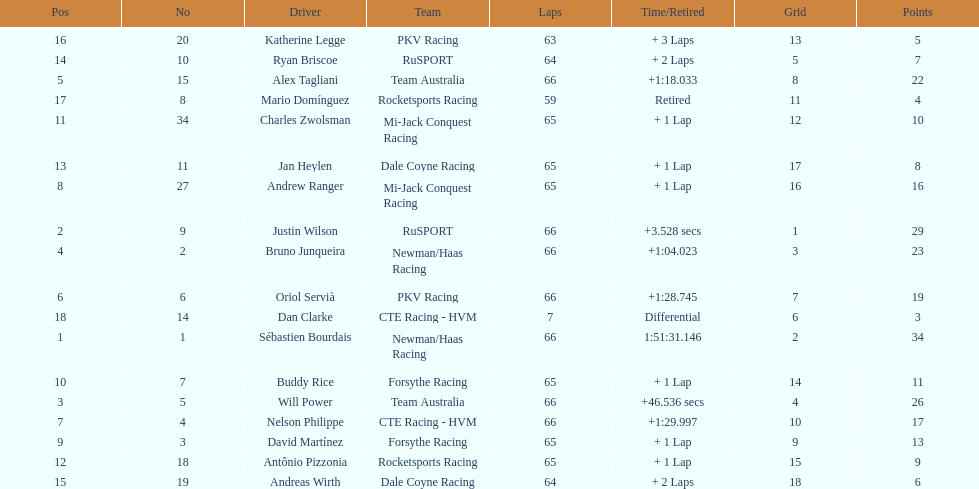Which country is represented by the most drivers? United Kingdom. 